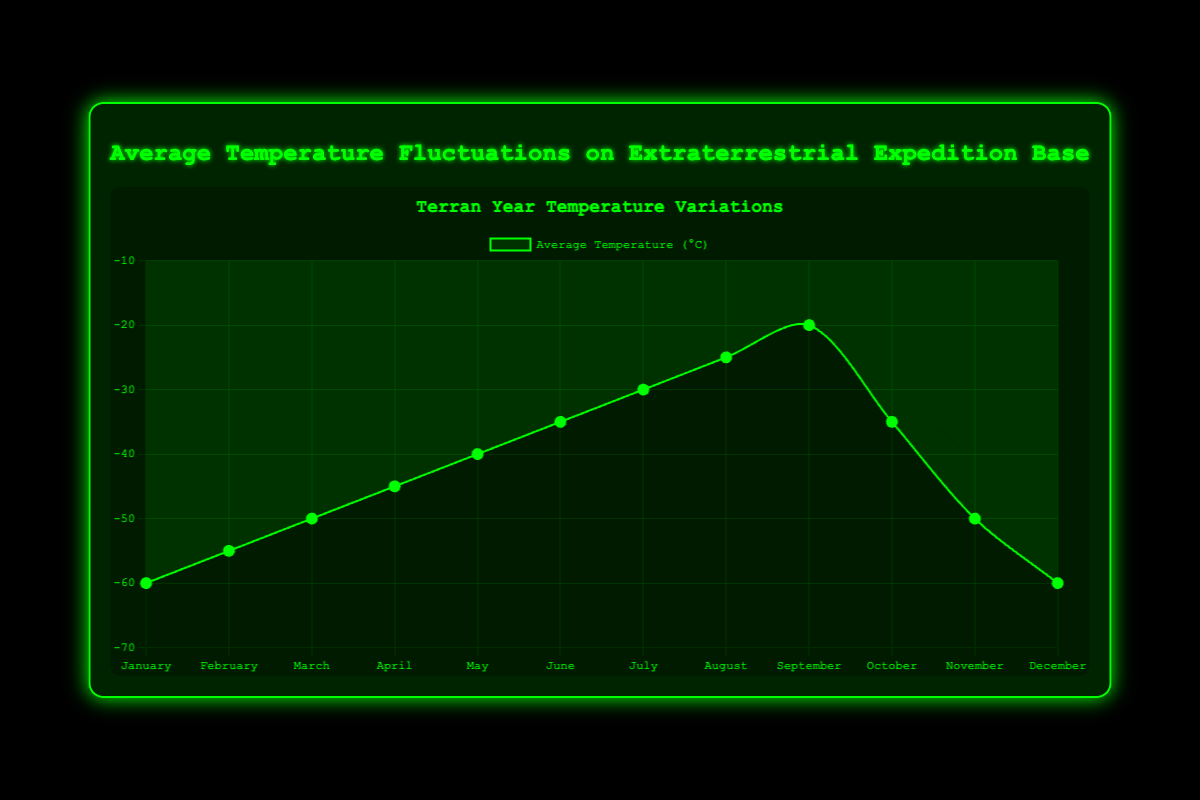What is the average temperature in September? The figure shows the average temperature data for each month. In September, the average temperature is indicated at -20°C.
Answer: -20°C Which month has the highest average temperature? Observing the line graph, the highest point occurs in September, indicating that September has the highest average temperature of -20°C.
Answer: September Which month has the same average temperature as October? By comparing the temperature values, it is clear that both June and October have an average temperature of -35°C.
Answer: June How does the average temperature in January compare to December? The figure shows that both January and December have the same average temperature of -60°C. Therefore, they are equal.
Answer: Equal Which month experiences the greatest drop in average temperature compared to the previous month? The largest drop in the line plot occurs between September and October, dropping from -20°C to -35°C, showing a 15°C decline.
Answer: October Calculate the difference in average temperature between the warmest and coldest months. The warmest month is September at -20°C, and the coldest months are January and December at -60°C. Difference is calculated as \( -20 - (-60) = 40 \).
Answer: 40°C What trend is observed between January and September regarding average temperature changes? From January to September, the figure shows a steady increase in average temperature from -60°C to -20°C.
Answer: Steady increase Identify any outliers in the temperature trend pattern over the year. Primarily, the temperature steadily rises from January to September, peaks, and then declines sharply from October to December, creating an outlier in the trend for October.
Answer: October Which period shows the steepest climb in average temperatures? Between April and September, the increase is noticeable, but the steepest climb is from August to September, going from -25°C to -20°C.
Answer: August to September How does the average temperature in November compare to the temperature in March? November's average temperature is -50°C, which matches exactly the temperature in March at -50°C, showing they are equal.
Answer: Equal 